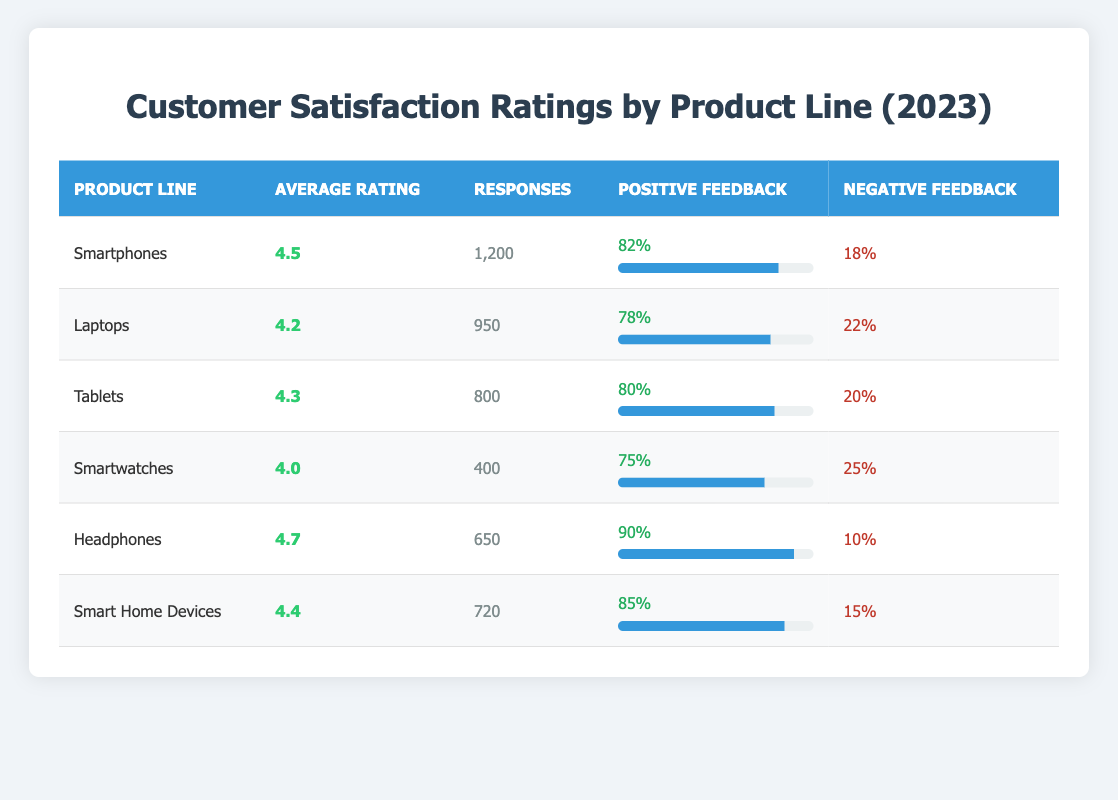What is the average rating for the Laptops product line? The table indicates the average rating for Laptops is found in the "Average Rating" column. Looking at the row for Laptops, the value is 4.2.
Answer: 4.2 Which product line received the highest positive feedback percentage? The "Positive Feedback" column displays the positive feedback percentage for each product line. Scanning through these values, Headphones has the highest percentage at 90%.
Answer: Headphones How many total responses were received for all product lines combined? To find the total responses, add the "Number of Responses" across all product lines: 1200 (Smartphones) + 950 (Laptops) + 800 (Tablets) + 400 (Smartwatches) + 650 (Headphones) + 720 (Smart Home Devices) = 3720.
Answer: 3720 Is the negative feedback percentage for Smart Home Devices greater than 20%? The negative feedback percentage for Smart Home Devices is 15%, which is less than 20%. Therefore, it is false that it is greater than 20%.
Answer: No What is the average rating for the Smart devices (Smartphones, Smartwatches, and Smart Home Devices)? To find the average rating for Smart devices, sum their ratings: 4.5 (Smartphones) + 4.0 (Smartwatches) + 4.4 (Smart Home Devices) = 12.9. Then, divide by the number of Smart devices, which is 3: 12.9 / 3 = 4.3.
Answer: 4.3 Which product line has the lowest average rating, and what is that rating? By examining the "Average Rating" column, the lowest value is found in the Smartwatches row, which has an average rating of 4.0.
Answer: Smartwatches, 4.0 Is the positive feedback percentage for Tablets higher than for Laptops? Tablets have a positive feedback percentage of 80%, while Laptops have 78%. Since 80% is greater than 78%, the statement is true.
Answer: Yes What is the difference in negative feedback percentage between the product line with the least and most negative feedback? Headphones has the least negative feedback at 10% and Smartwatches has the highest at 25%. The difference is 25% - 10% = 15%.
Answer: 15% 